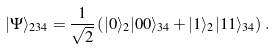Convert formula to latex. <formula><loc_0><loc_0><loc_500><loc_500>| \Psi \rangle _ { 2 3 4 } = \frac { 1 } { \sqrt { 2 } } \left ( | 0 \rangle _ { 2 } | 0 0 \rangle _ { 3 4 } + | 1 \rangle _ { 2 } | 1 1 \rangle _ { 3 4 } \right ) \, .</formula> 